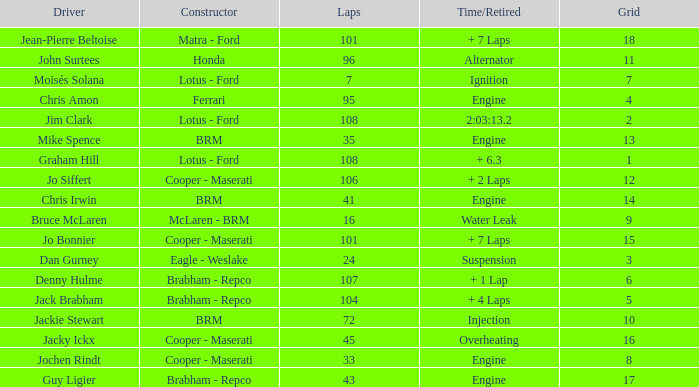What was the grid for suspension time/retired? 3.0. 